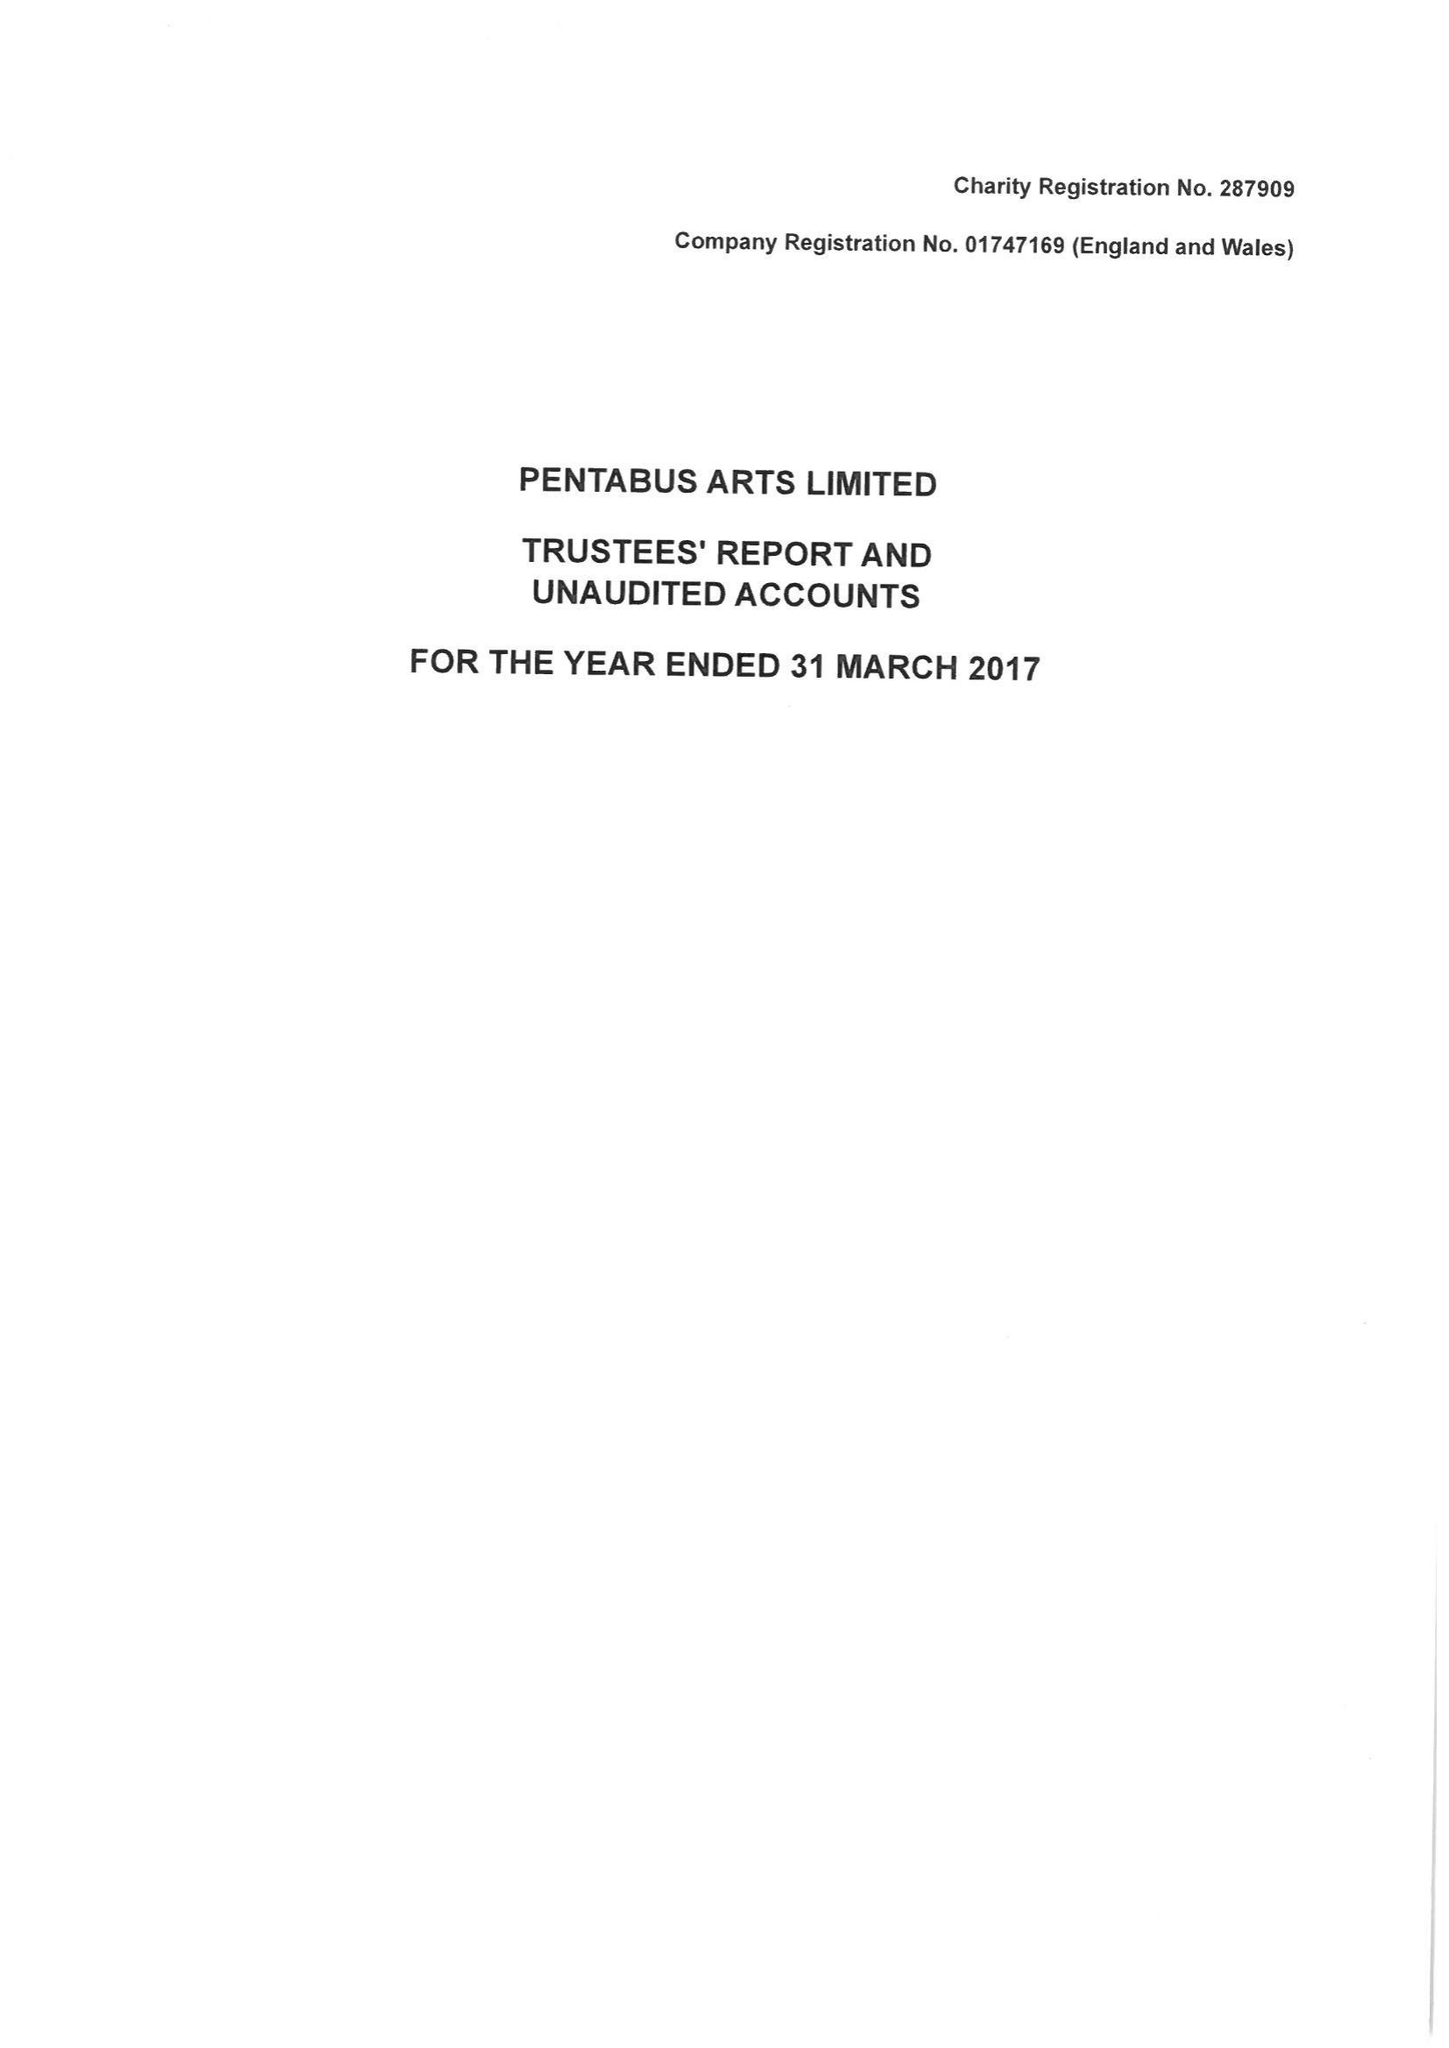What is the value for the address__street_line?
Answer the question using a single word or phrase. None 